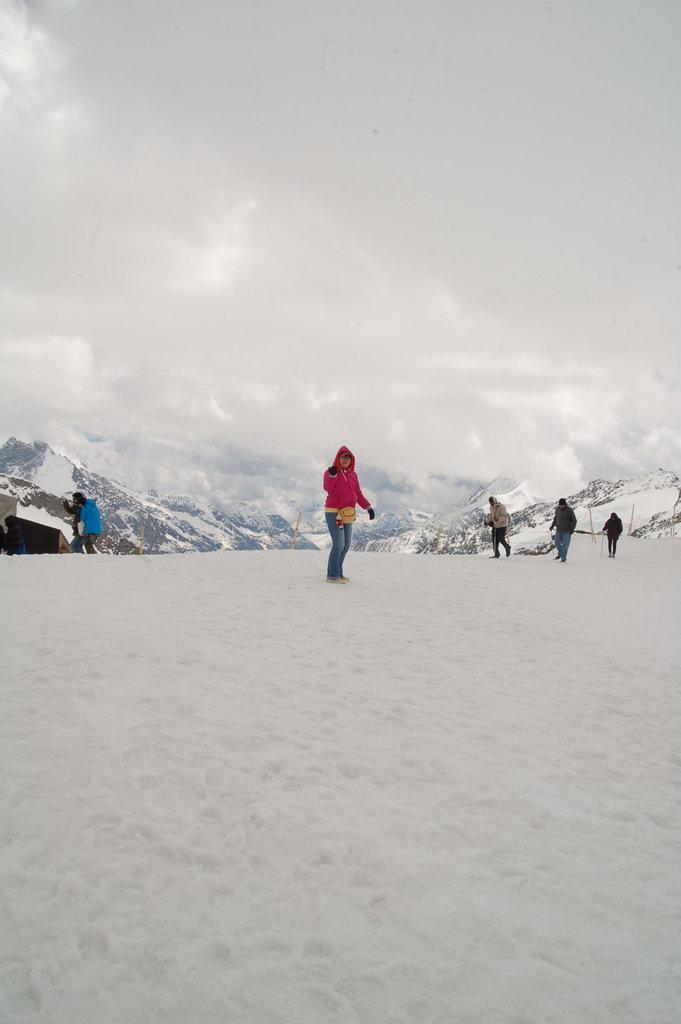What is the setting of the image? The setting of the image is on snowy mountains. What can be seen in the background of the image? There are snowy mountains in the background. What is the condition of the sky in the image? The sky contains clouds. What type of plate is being used for digestion in the image? There is no plate or reference to digestion present in the image. 